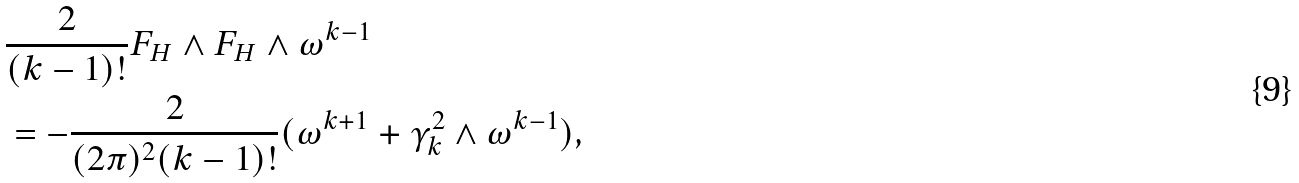Convert formula to latex. <formula><loc_0><loc_0><loc_500><loc_500>& \frac { 2 } { ( k - 1 ) ! } F _ { H } \wedge F _ { H } \wedge \omega ^ { k - 1 } \\ & = - \frac { 2 } { ( 2 \pi ) ^ { 2 } ( k - 1 ) ! } ( \omega ^ { k + 1 } + \gamma _ { k } ^ { 2 } \wedge \omega ^ { k - 1 } ) ,</formula> 